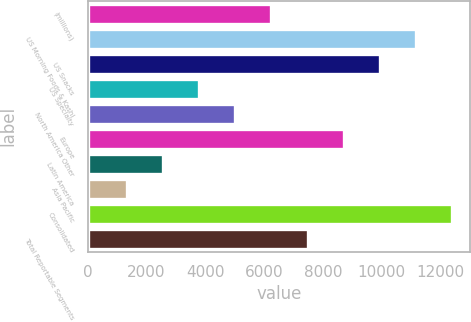Convert chart to OTSL. <chart><loc_0><loc_0><loc_500><loc_500><bar_chart><fcel>(millions)<fcel>US Morning Foods & Kashi<fcel>US Snacks<fcel>US Specialty<fcel>North America Other<fcel>Europe<fcel>Latin America<fcel>Asia Pacific<fcel>Consolidated<fcel>Total Reportable Segments<nl><fcel>6247.5<fcel>11167.1<fcel>9937.2<fcel>3787.7<fcel>5017.6<fcel>8707.3<fcel>2557.8<fcel>1327.9<fcel>12397<fcel>7477.4<nl></chart> 